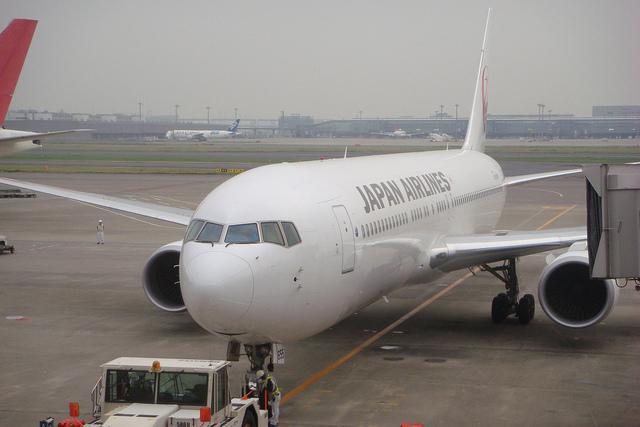How many airplanes are there?
Give a very brief answer. 2. 